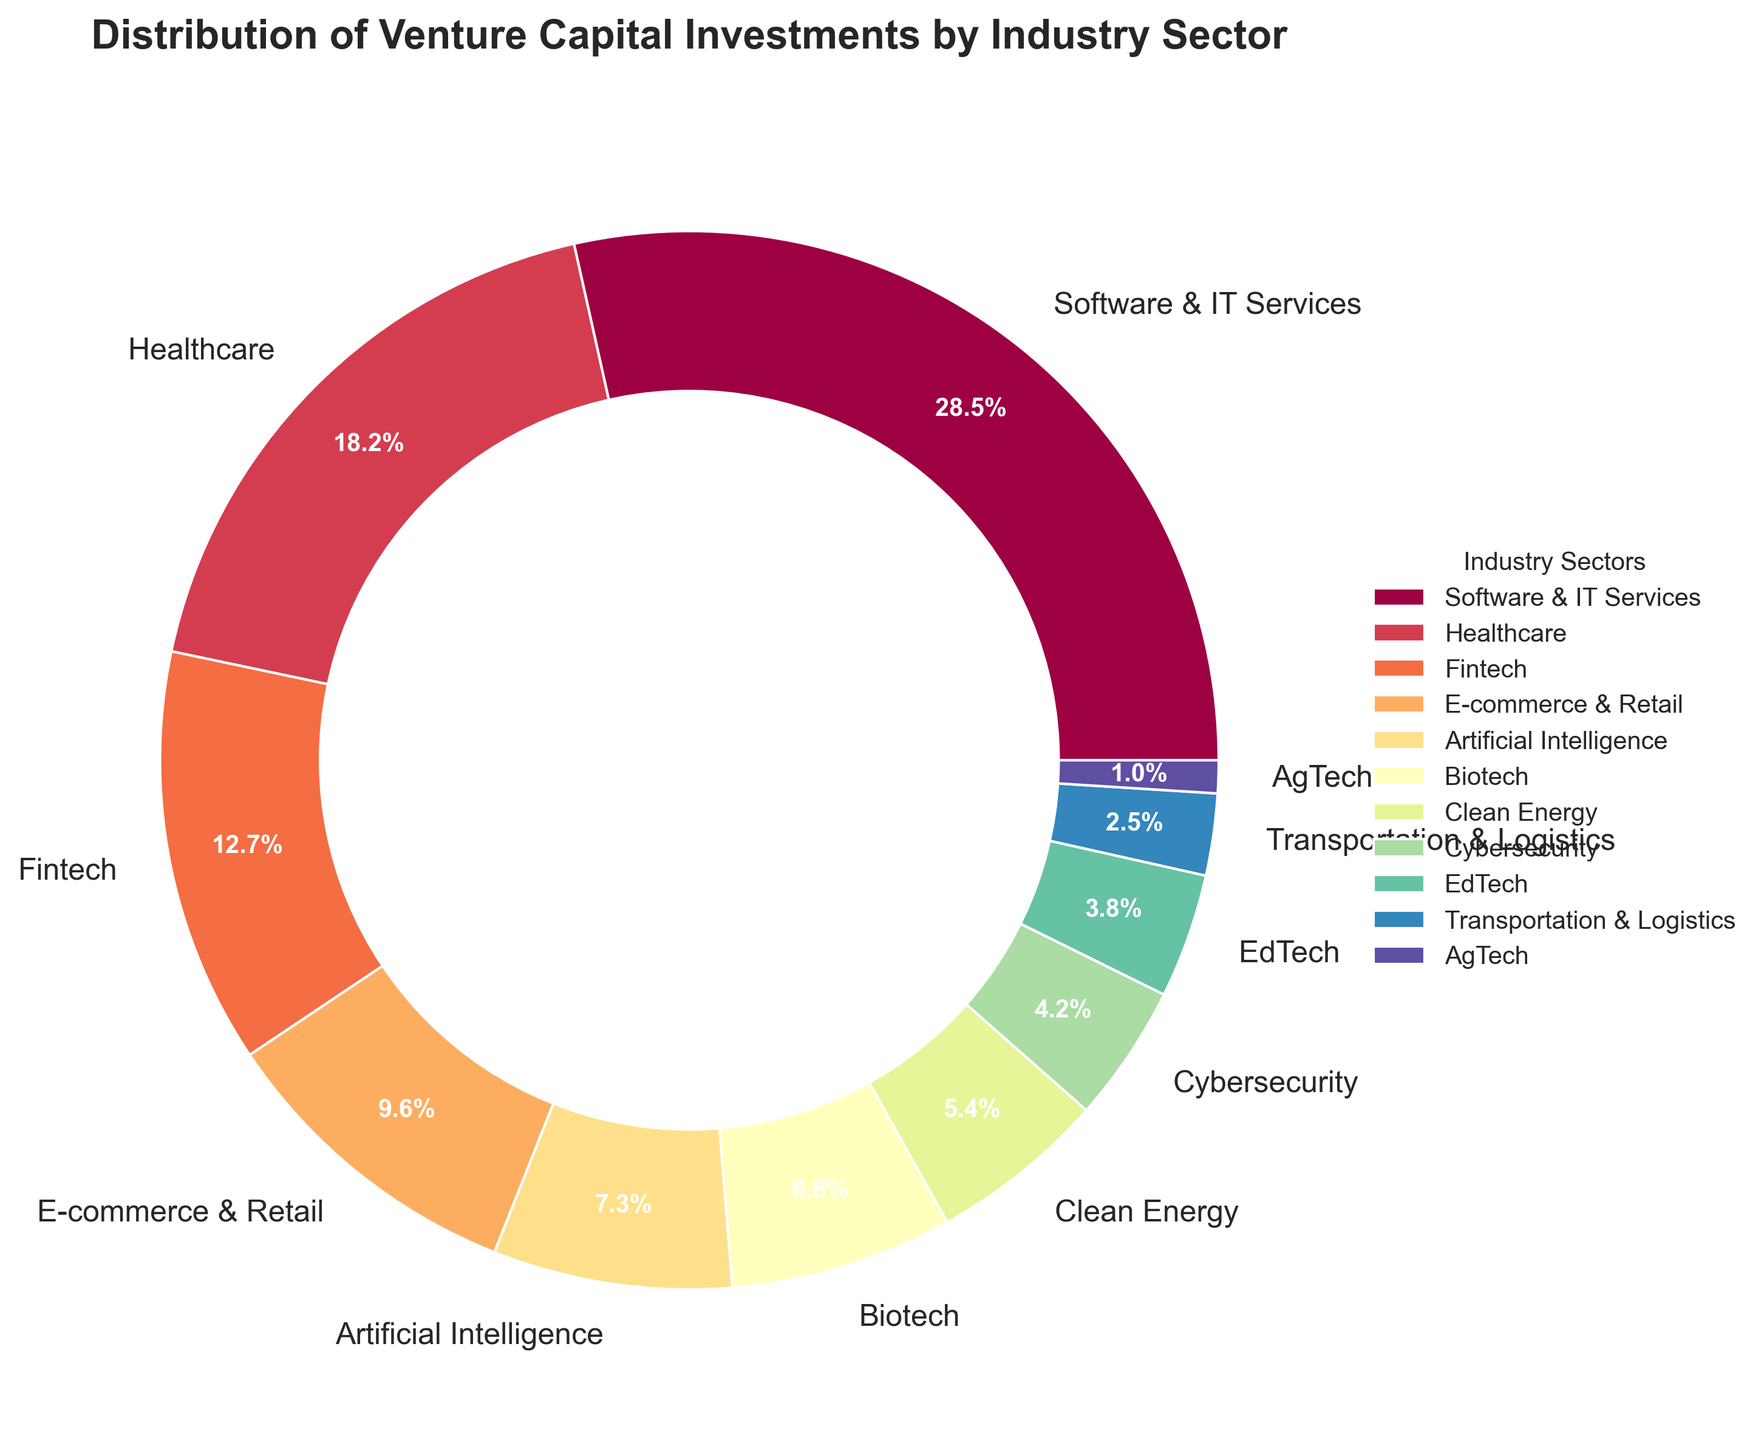What are the three industry sectors with the largest percentage of venture capital investments? The sectors with the largest percentages can be identified from the pie chart by looking at the size of the slices. The three largest segments represent Software & IT Services, Healthcare, and Fintech.
Answer: Software & IT Services, Healthcare, Fintech Which industry sector has the smallest percentage share in venture capital investments, and what is that percentage? To find the smallest percentage share, identify the smallest slice in the pie chart. The smallest slice corresponds to AgTech, with a percentage of 1.0%.
Answer: AgTech, 1.0% What is the combined percentage share of Healthcare and Fintech sectors? To find the combined percentage, sum the individual percentages of Healthcare (18.2%) and Fintech (12.7%). Thus, 18.2 + 12.7 = 30.9%.
Answer: 30.9% What percentage more does Software & IT Services receive compared to EdTech? First, identify the percentages for Software & IT Services (28.5%) and EdTech (3.8%). Then subtract EdTech's percentage from Software & IT Services' percentage: 28.5% - 3.8% = 24.7%.
Answer: 24.7% Which two sectors together make up approximately 14% of venture capital investments? Identify sectors whose combined percentages total approximately 14%. Clean Energy (5.4%) and Cybersecurity (4.2%) add up to 9.6%, while Cybersecurity (4.2%) and EdTech (3.8%) sum to 8%. Clean Energy (5.4%) and Biotech (6.8%) sum to 12.2%. The closest match is EdTech (3.8%) and Transportation & Logistics (2.5%), totaling 6.3%.
Answer: No exact match; Clean Energy and Biotech are closest at 12.2% Which sector has nearly twice the investment percentage share of Clean Energy? First, find Clean Energy's percentage (5.4%). Then, look for a sector close to twice this percentage. Twice 5.4 is around 10.8. The closest sectors are Fintech (12.7%) and E-commerce & Retail (9.6%). Fintech is closest to being twice but not exactly.
Answer: Fintech Arrange the following sectors in decreasing order of their investment share: Artificial Intelligence, Biotech, EdTech, Clean Energy. The percentages for the sectors are: Artificial Intelligence (7.3%), Biotech (6.8%), EdTech (3.8%), Clean Energy (5.4%). Arrange them in decreasing order based on these values.
Answer: Artificial Intelligence, Clean Energy, Biotech, EdTech How much more in percentage does the Transportation & Logistics sector receive compared to the AgTech sector? Identify the percentages for Transportation & Logistics (2.5%) and AgTech (1.0%). Subtract AgTech's percentage from Transportation & Logistics' percentage: 2.5% - 1.0% = 1.5%.
Answer: 1.5% What is the total percentage share of industries receiving less than 5% of venture capital investments each? Identify sectors with less than 5%: Clean Energy (5.4%), Cybersecurity (4.2%), EdTech (3.8%), Transportation & Logistics (2.5%), and AgTech (1.0%). Sum up their percentages: 4.2 + 3.8 + 2.5 + 1.0 = 11.5 (excluding Clean Energy as it exceeds 5%).
Answer: 11.5% Which industry sectors collectively account for just over half of the venture capital investments? First, look for sectors whose combined percentages add up to a little over 50%. Software & IT Services (28.5%) and Healthcare (18.2%) together make 46.7%. Including Fintech (12.7%) gives 59.4%, which is just over half.
Answer: Software & IT Services, Healthcare, Fintech 